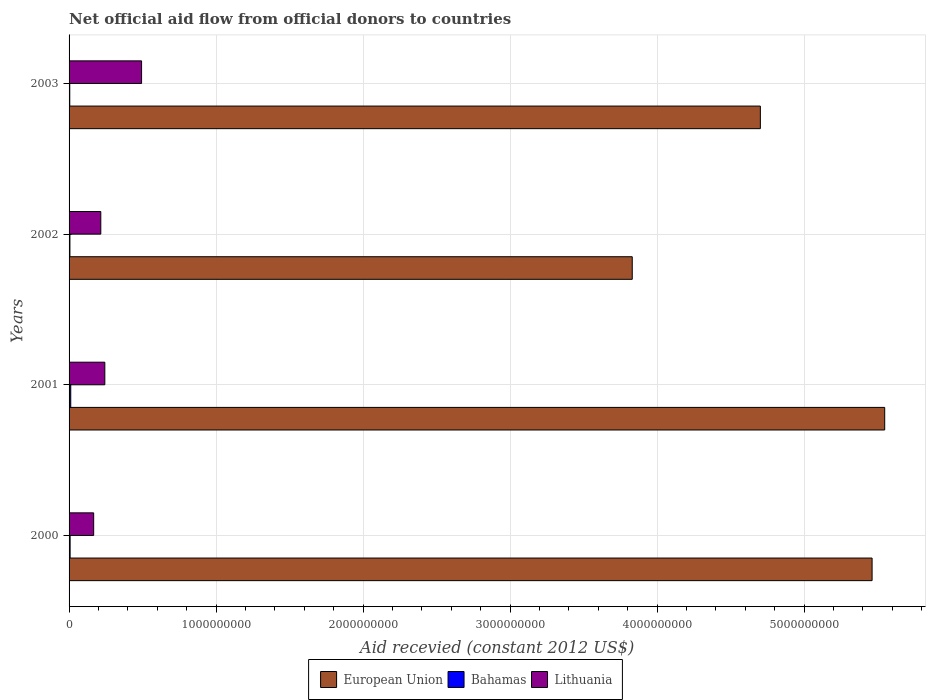How many different coloured bars are there?
Your answer should be compact. 3. How many groups of bars are there?
Provide a short and direct response. 4. Are the number of bars per tick equal to the number of legend labels?
Your response must be concise. Yes. What is the label of the 2nd group of bars from the top?
Offer a terse response. 2002. In how many cases, is the number of bars for a given year not equal to the number of legend labels?
Your answer should be very brief. 0. What is the total aid received in European Union in 2003?
Make the answer very short. 4.70e+09. Across all years, what is the maximum total aid received in Lithuania?
Provide a succinct answer. 4.93e+08. Across all years, what is the minimum total aid received in Bahamas?
Make the answer very short. 4.76e+06. In which year was the total aid received in European Union minimum?
Provide a short and direct response. 2002. What is the total total aid received in Bahamas in the graph?
Provide a short and direct response. 2.90e+07. What is the difference between the total aid received in European Union in 2000 and that in 2002?
Ensure brevity in your answer.  1.63e+09. What is the difference between the total aid received in Bahamas in 2000 and the total aid received in European Union in 2002?
Offer a very short reply. -3.82e+09. What is the average total aid received in Lithuania per year?
Your answer should be compact. 2.80e+08. In the year 2002, what is the difference between the total aid received in Lithuania and total aid received in Bahamas?
Offer a terse response. 2.10e+08. In how many years, is the total aid received in Lithuania greater than 2200000000 US$?
Give a very brief answer. 0. What is the ratio of the total aid received in European Union in 2000 to that in 2002?
Your answer should be very brief. 1.43. Is the total aid received in Bahamas in 2001 less than that in 2003?
Ensure brevity in your answer.  No. Is the difference between the total aid received in Lithuania in 2000 and 2003 greater than the difference between the total aid received in Bahamas in 2000 and 2003?
Provide a short and direct response. No. What is the difference between the highest and the second highest total aid received in Lithuania?
Offer a very short reply. 2.50e+08. What is the difference between the highest and the lowest total aid received in European Union?
Make the answer very short. 1.72e+09. What does the 2nd bar from the top in 2000 represents?
Offer a very short reply. Bahamas. What does the 2nd bar from the bottom in 2003 represents?
Keep it short and to the point. Bahamas. Is it the case that in every year, the sum of the total aid received in Bahamas and total aid received in Lithuania is greater than the total aid received in European Union?
Your answer should be compact. No. What is the difference between two consecutive major ticks on the X-axis?
Make the answer very short. 1.00e+09. Where does the legend appear in the graph?
Your answer should be very brief. Bottom center. What is the title of the graph?
Ensure brevity in your answer.  Net official aid flow from official donors to countries. Does "Kazakhstan" appear as one of the legend labels in the graph?
Provide a short and direct response. No. What is the label or title of the X-axis?
Offer a very short reply. Aid recevied (constant 2012 US$). What is the label or title of the Y-axis?
Offer a very short reply. Years. What is the Aid recevied (constant 2012 US$) of European Union in 2000?
Your answer should be compact. 5.46e+09. What is the Aid recevied (constant 2012 US$) in Bahamas in 2000?
Your answer should be compact. 7.08e+06. What is the Aid recevied (constant 2012 US$) of Lithuania in 2000?
Offer a very short reply. 1.67e+08. What is the Aid recevied (constant 2012 US$) in European Union in 2001?
Keep it short and to the point. 5.55e+09. What is the Aid recevied (constant 2012 US$) in Bahamas in 2001?
Your answer should be very brief. 1.14e+07. What is the Aid recevied (constant 2012 US$) of Lithuania in 2001?
Offer a terse response. 2.43e+08. What is the Aid recevied (constant 2012 US$) in European Union in 2002?
Your answer should be very brief. 3.83e+09. What is the Aid recevied (constant 2012 US$) of Bahamas in 2002?
Your answer should be very brief. 5.78e+06. What is the Aid recevied (constant 2012 US$) of Lithuania in 2002?
Offer a terse response. 2.16e+08. What is the Aid recevied (constant 2012 US$) in European Union in 2003?
Your response must be concise. 4.70e+09. What is the Aid recevied (constant 2012 US$) of Bahamas in 2003?
Your answer should be compact. 4.76e+06. What is the Aid recevied (constant 2012 US$) of Lithuania in 2003?
Your answer should be very brief. 4.93e+08. Across all years, what is the maximum Aid recevied (constant 2012 US$) of European Union?
Provide a succinct answer. 5.55e+09. Across all years, what is the maximum Aid recevied (constant 2012 US$) in Bahamas?
Provide a succinct answer. 1.14e+07. Across all years, what is the maximum Aid recevied (constant 2012 US$) in Lithuania?
Provide a succinct answer. 4.93e+08. Across all years, what is the minimum Aid recevied (constant 2012 US$) of European Union?
Give a very brief answer. 3.83e+09. Across all years, what is the minimum Aid recevied (constant 2012 US$) in Bahamas?
Your response must be concise. 4.76e+06. Across all years, what is the minimum Aid recevied (constant 2012 US$) of Lithuania?
Offer a very short reply. 1.67e+08. What is the total Aid recevied (constant 2012 US$) of European Union in the graph?
Give a very brief answer. 1.95e+1. What is the total Aid recevied (constant 2012 US$) of Bahamas in the graph?
Ensure brevity in your answer.  2.90e+07. What is the total Aid recevied (constant 2012 US$) of Lithuania in the graph?
Provide a short and direct response. 1.12e+09. What is the difference between the Aid recevied (constant 2012 US$) of European Union in 2000 and that in 2001?
Offer a very short reply. -8.58e+07. What is the difference between the Aid recevied (constant 2012 US$) in Bahamas in 2000 and that in 2001?
Offer a very short reply. -4.30e+06. What is the difference between the Aid recevied (constant 2012 US$) of Lithuania in 2000 and that in 2001?
Your answer should be very brief. -7.60e+07. What is the difference between the Aid recevied (constant 2012 US$) of European Union in 2000 and that in 2002?
Provide a short and direct response. 1.63e+09. What is the difference between the Aid recevied (constant 2012 US$) of Bahamas in 2000 and that in 2002?
Make the answer very short. 1.30e+06. What is the difference between the Aid recevied (constant 2012 US$) in Lithuania in 2000 and that in 2002?
Keep it short and to the point. -4.85e+07. What is the difference between the Aid recevied (constant 2012 US$) of European Union in 2000 and that in 2003?
Provide a short and direct response. 7.60e+08. What is the difference between the Aid recevied (constant 2012 US$) of Bahamas in 2000 and that in 2003?
Ensure brevity in your answer.  2.32e+06. What is the difference between the Aid recevied (constant 2012 US$) of Lithuania in 2000 and that in 2003?
Offer a very short reply. -3.26e+08. What is the difference between the Aid recevied (constant 2012 US$) in European Union in 2001 and that in 2002?
Your answer should be very brief. 1.72e+09. What is the difference between the Aid recevied (constant 2012 US$) in Bahamas in 2001 and that in 2002?
Provide a succinct answer. 5.60e+06. What is the difference between the Aid recevied (constant 2012 US$) of Lithuania in 2001 and that in 2002?
Provide a short and direct response. 2.74e+07. What is the difference between the Aid recevied (constant 2012 US$) in European Union in 2001 and that in 2003?
Provide a succinct answer. 8.46e+08. What is the difference between the Aid recevied (constant 2012 US$) of Bahamas in 2001 and that in 2003?
Your answer should be very brief. 6.62e+06. What is the difference between the Aid recevied (constant 2012 US$) of Lithuania in 2001 and that in 2003?
Provide a succinct answer. -2.50e+08. What is the difference between the Aid recevied (constant 2012 US$) of European Union in 2002 and that in 2003?
Your response must be concise. -8.71e+08. What is the difference between the Aid recevied (constant 2012 US$) of Bahamas in 2002 and that in 2003?
Ensure brevity in your answer.  1.02e+06. What is the difference between the Aid recevied (constant 2012 US$) in Lithuania in 2002 and that in 2003?
Your response must be concise. -2.77e+08. What is the difference between the Aid recevied (constant 2012 US$) in European Union in 2000 and the Aid recevied (constant 2012 US$) in Bahamas in 2001?
Provide a succinct answer. 5.45e+09. What is the difference between the Aid recevied (constant 2012 US$) of European Union in 2000 and the Aid recevied (constant 2012 US$) of Lithuania in 2001?
Offer a terse response. 5.22e+09. What is the difference between the Aid recevied (constant 2012 US$) of Bahamas in 2000 and the Aid recevied (constant 2012 US$) of Lithuania in 2001?
Give a very brief answer. -2.36e+08. What is the difference between the Aid recevied (constant 2012 US$) of European Union in 2000 and the Aid recevied (constant 2012 US$) of Bahamas in 2002?
Your answer should be very brief. 5.46e+09. What is the difference between the Aid recevied (constant 2012 US$) of European Union in 2000 and the Aid recevied (constant 2012 US$) of Lithuania in 2002?
Your answer should be compact. 5.25e+09. What is the difference between the Aid recevied (constant 2012 US$) in Bahamas in 2000 and the Aid recevied (constant 2012 US$) in Lithuania in 2002?
Your response must be concise. -2.09e+08. What is the difference between the Aid recevied (constant 2012 US$) in European Union in 2000 and the Aid recevied (constant 2012 US$) in Bahamas in 2003?
Provide a succinct answer. 5.46e+09. What is the difference between the Aid recevied (constant 2012 US$) of European Union in 2000 and the Aid recevied (constant 2012 US$) of Lithuania in 2003?
Offer a terse response. 4.97e+09. What is the difference between the Aid recevied (constant 2012 US$) of Bahamas in 2000 and the Aid recevied (constant 2012 US$) of Lithuania in 2003?
Your answer should be compact. -4.86e+08. What is the difference between the Aid recevied (constant 2012 US$) in European Union in 2001 and the Aid recevied (constant 2012 US$) in Bahamas in 2002?
Your answer should be very brief. 5.54e+09. What is the difference between the Aid recevied (constant 2012 US$) of European Union in 2001 and the Aid recevied (constant 2012 US$) of Lithuania in 2002?
Keep it short and to the point. 5.33e+09. What is the difference between the Aid recevied (constant 2012 US$) in Bahamas in 2001 and the Aid recevied (constant 2012 US$) in Lithuania in 2002?
Offer a terse response. -2.04e+08. What is the difference between the Aid recevied (constant 2012 US$) of European Union in 2001 and the Aid recevied (constant 2012 US$) of Bahamas in 2003?
Ensure brevity in your answer.  5.54e+09. What is the difference between the Aid recevied (constant 2012 US$) in European Union in 2001 and the Aid recevied (constant 2012 US$) in Lithuania in 2003?
Keep it short and to the point. 5.05e+09. What is the difference between the Aid recevied (constant 2012 US$) of Bahamas in 2001 and the Aid recevied (constant 2012 US$) of Lithuania in 2003?
Provide a short and direct response. -4.82e+08. What is the difference between the Aid recevied (constant 2012 US$) of European Union in 2002 and the Aid recevied (constant 2012 US$) of Bahamas in 2003?
Offer a very short reply. 3.83e+09. What is the difference between the Aid recevied (constant 2012 US$) of European Union in 2002 and the Aid recevied (constant 2012 US$) of Lithuania in 2003?
Provide a short and direct response. 3.34e+09. What is the difference between the Aid recevied (constant 2012 US$) in Bahamas in 2002 and the Aid recevied (constant 2012 US$) in Lithuania in 2003?
Offer a very short reply. -4.87e+08. What is the average Aid recevied (constant 2012 US$) in European Union per year?
Provide a succinct answer. 4.89e+09. What is the average Aid recevied (constant 2012 US$) in Bahamas per year?
Your answer should be compact. 7.25e+06. What is the average Aid recevied (constant 2012 US$) of Lithuania per year?
Provide a short and direct response. 2.80e+08. In the year 2000, what is the difference between the Aid recevied (constant 2012 US$) of European Union and Aid recevied (constant 2012 US$) of Bahamas?
Ensure brevity in your answer.  5.46e+09. In the year 2000, what is the difference between the Aid recevied (constant 2012 US$) in European Union and Aid recevied (constant 2012 US$) in Lithuania?
Your response must be concise. 5.29e+09. In the year 2000, what is the difference between the Aid recevied (constant 2012 US$) of Bahamas and Aid recevied (constant 2012 US$) of Lithuania?
Your answer should be compact. -1.60e+08. In the year 2001, what is the difference between the Aid recevied (constant 2012 US$) of European Union and Aid recevied (constant 2012 US$) of Bahamas?
Offer a terse response. 5.54e+09. In the year 2001, what is the difference between the Aid recevied (constant 2012 US$) in European Union and Aid recevied (constant 2012 US$) in Lithuania?
Make the answer very short. 5.30e+09. In the year 2001, what is the difference between the Aid recevied (constant 2012 US$) in Bahamas and Aid recevied (constant 2012 US$) in Lithuania?
Provide a short and direct response. -2.32e+08. In the year 2002, what is the difference between the Aid recevied (constant 2012 US$) in European Union and Aid recevied (constant 2012 US$) in Bahamas?
Your response must be concise. 3.82e+09. In the year 2002, what is the difference between the Aid recevied (constant 2012 US$) in European Union and Aid recevied (constant 2012 US$) in Lithuania?
Your response must be concise. 3.61e+09. In the year 2002, what is the difference between the Aid recevied (constant 2012 US$) of Bahamas and Aid recevied (constant 2012 US$) of Lithuania?
Offer a very short reply. -2.10e+08. In the year 2003, what is the difference between the Aid recevied (constant 2012 US$) in European Union and Aid recevied (constant 2012 US$) in Bahamas?
Your answer should be very brief. 4.70e+09. In the year 2003, what is the difference between the Aid recevied (constant 2012 US$) of European Union and Aid recevied (constant 2012 US$) of Lithuania?
Your answer should be very brief. 4.21e+09. In the year 2003, what is the difference between the Aid recevied (constant 2012 US$) in Bahamas and Aid recevied (constant 2012 US$) in Lithuania?
Your response must be concise. -4.88e+08. What is the ratio of the Aid recevied (constant 2012 US$) in European Union in 2000 to that in 2001?
Your response must be concise. 0.98. What is the ratio of the Aid recevied (constant 2012 US$) of Bahamas in 2000 to that in 2001?
Make the answer very short. 0.62. What is the ratio of the Aid recevied (constant 2012 US$) of Lithuania in 2000 to that in 2001?
Your answer should be very brief. 0.69. What is the ratio of the Aid recevied (constant 2012 US$) of European Union in 2000 to that in 2002?
Provide a succinct answer. 1.43. What is the ratio of the Aid recevied (constant 2012 US$) in Bahamas in 2000 to that in 2002?
Provide a succinct answer. 1.22. What is the ratio of the Aid recevied (constant 2012 US$) in Lithuania in 2000 to that in 2002?
Make the answer very short. 0.78. What is the ratio of the Aid recevied (constant 2012 US$) in European Union in 2000 to that in 2003?
Offer a terse response. 1.16. What is the ratio of the Aid recevied (constant 2012 US$) in Bahamas in 2000 to that in 2003?
Your answer should be compact. 1.49. What is the ratio of the Aid recevied (constant 2012 US$) of Lithuania in 2000 to that in 2003?
Your answer should be compact. 0.34. What is the ratio of the Aid recevied (constant 2012 US$) of European Union in 2001 to that in 2002?
Provide a succinct answer. 1.45. What is the ratio of the Aid recevied (constant 2012 US$) of Bahamas in 2001 to that in 2002?
Ensure brevity in your answer.  1.97. What is the ratio of the Aid recevied (constant 2012 US$) in Lithuania in 2001 to that in 2002?
Give a very brief answer. 1.13. What is the ratio of the Aid recevied (constant 2012 US$) of European Union in 2001 to that in 2003?
Your answer should be very brief. 1.18. What is the ratio of the Aid recevied (constant 2012 US$) in Bahamas in 2001 to that in 2003?
Your answer should be very brief. 2.39. What is the ratio of the Aid recevied (constant 2012 US$) of Lithuania in 2001 to that in 2003?
Keep it short and to the point. 0.49. What is the ratio of the Aid recevied (constant 2012 US$) in European Union in 2002 to that in 2003?
Provide a short and direct response. 0.81. What is the ratio of the Aid recevied (constant 2012 US$) in Bahamas in 2002 to that in 2003?
Your answer should be compact. 1.21. What is the ratio of the Aid recevied (constant 2012 US$) of Lithuania in 2002 to that in 2003?
Provide a succinct answer. 0.44. What is the difference between the highest and the second highest Aid recevied (constant 2012 US$) of European Union?
Your answer should be compact. 8.58e+07. What is the difference between the highest and the second highest Aid recevied (constant 2012 US$) in Bahamas?
Make the answer very short. 4.30e+06. What is the difference between the highest and the second highest Aid recevied (constant 2012 US$) of Lithuania?
Keep it short and to the point. 2.50e+08. What is the difference between the highest and the lowest Aid recevied (constant 2012 US$) in European Union?
Provide a short and direct response. 1.72e+09. What is the difference between the highest and the lowest Aid recevied (constant 2012 US$) of Bahamas?
Your answer should be very brief. 6.62e+06. What is the difference between the highest and the lowest Aid recevied (constant 2012 US$) in Lithuania?
Make the answer very short. 3.26e+08. 